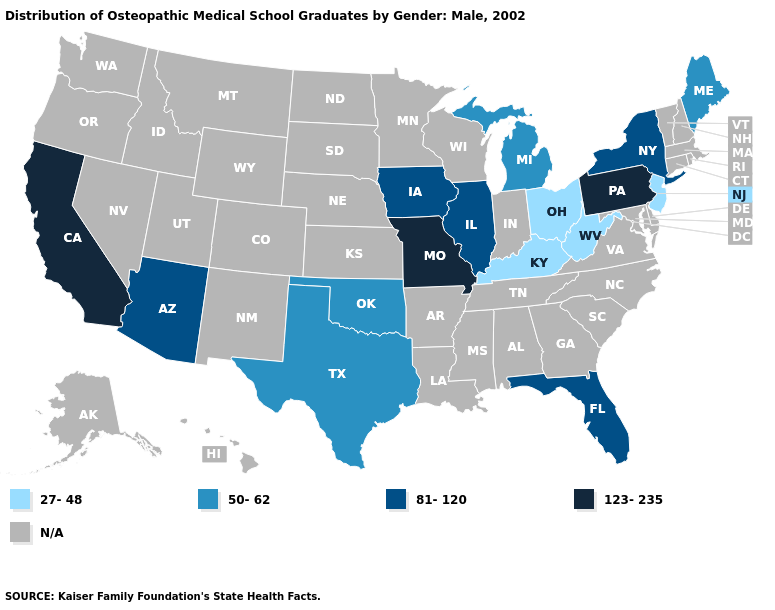What is the highest value in the USA?
Concise answer only. 123-235. Which states have the lowest value in the USA?
Quick response, please. Kentucky, New Jersey, Ohio, West Virginia. What is the highest value in the USA?
Short answer required. 123-235. What is the value of Hawaii?
Be succinct. N/A. Which states have the lowest value in the USA?
Concise answer only. Kentucky, New Jersey, Ohio, West Virginia. Does Missouri have the highest value in the USA?
Short answer required. Yes. Name the states that have a value in the range 50-62?
Concise answer only. Maine, Michigan, Oklahoma, Texas. Does Pennsylvania have the highest value in the USA?
Give a very brief answer. Yes. Name the states that have a value in the range N/A?
Answer briefly. Alabama, Alaska, Arkansas, Colorado, Connecticut, Delaware, Georgia, Hawaii, Idaho, Indiana, Kansas, Louisiana, Maryland, Massachusetts, Minnesota, Mississippi, Montana, Nebraska, Nevada, New Hampshire, New Mexico, North Carolina, North Dakota, Oregon, Rhode Island, South Carolina, South Dakota, Tennessee, Utah, Vermont, Virginia, Washington, Wisconsin, Wyoming. What is the value of Delaware?
Give a very brief answer. N/A. What is the highest value in the USA?
Concise answer only. 123-235. What is the highest value in the USA?
Keep it brief. 123-235. Does the map have missing data?
Give a very brief answer. Yes. Name the states that have a value in the range 123-235?
Answer briefly. California, Missouri, Pennsylvania. 